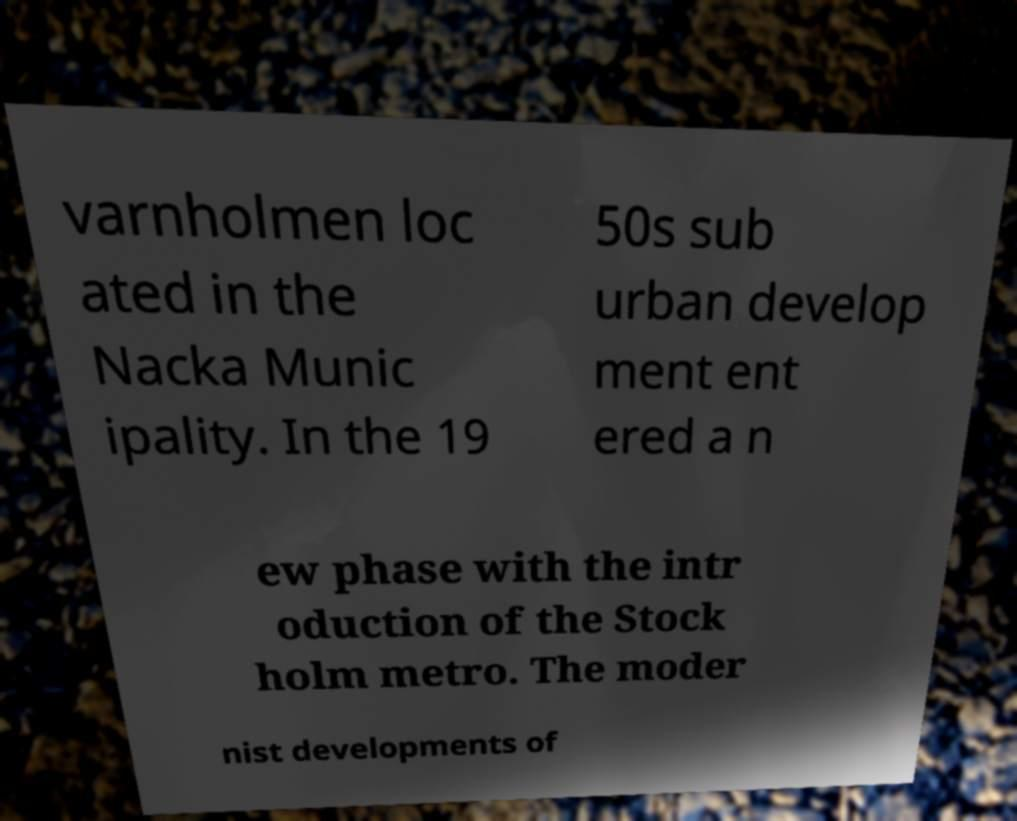I need the written content from this picture converted into text. Can you do that? varnholmen loc ated in the Nacka Munic ipality. In the 19 50s sub urban develop ment ent ered a n ew phase with the intr oduction of the Stock holm metro. The moder nist developments of 